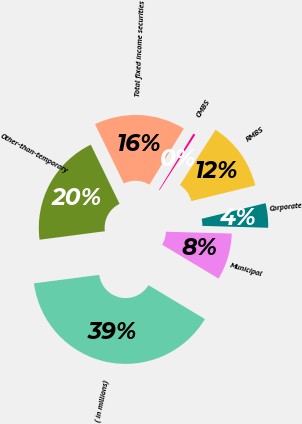<chart> <loc_0><loc_0><loc_500><loc_500><pie_chart><fcel>( in millions)<fcel>Municipal<fcel>Corporate<fcel>RMBS<fcel>CMBS<fcel>Total fixed income securities<fcel>Other-than-temporary<nl><fcel>39.33%<fcel>8.16%<fcel>4.27%<fcel>12.06%<fcel>0.37%<fcel>15.96%<fcel>19.85%<nl></chart> 